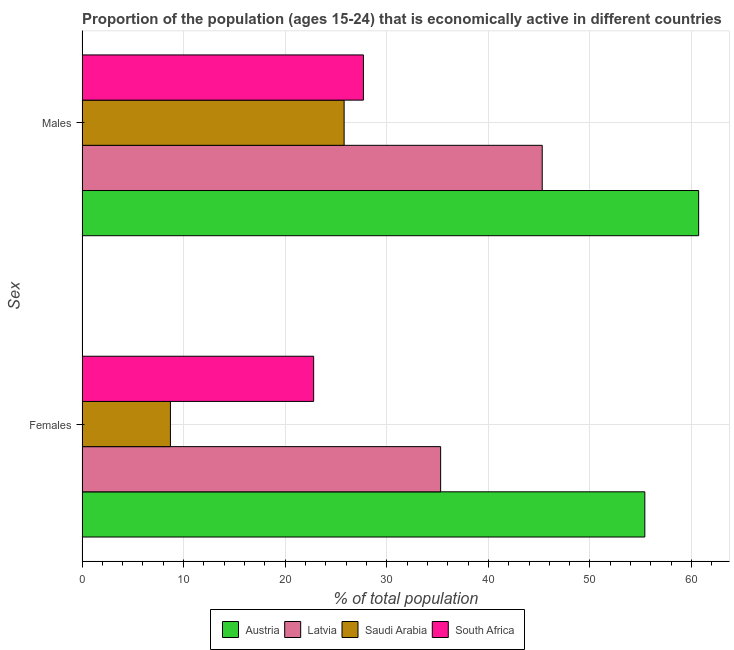Are the number of bars per tick equal to the number of legend labels?
Offer a terse response. Yes. Are the number of bars on each tick of the Y-axis equal?
Ensure brevity in your answer.  Yes. What is the label of the 2nd group of bars from the top?
Provide a succinct answer. Females. What is the percentage of economically active male population in Latvia?
Your answer should be compact. 45.3. Across all countries, what is the maximum percentage of economically active male population?
Offer a terse response. 60.7. Across all countries, what is the minimum percentage of economically active male population?
Offer a terse response. 25.8. In which country was the percentage of economically active female population minimum?
Keep it short and to the point. Saudi Arabia. What is the total percentage of economically active female population in the graph?
Make the answer very short. 122.2. What is the difference between the percentage of economically active female population in South Africa and that in Latvia?
Provide a succinct answer. -12.5. What is the difference between the percentage of economically active male population in Latvia and the percentage of economically active female population in South Africa?
Give a very brief answer. 22.5. What is the average percentage of economically active female population per country?
Ensure brevity in your answer.  30.55. What is the difference between the percentage of economically active male population and percentage of economically active female population in Latvia?
Provide a succinct answer. 10. What is the ratio of the percentage of economically active female population in Austria to that in Latvia?
Your response must be concise. 1.57. In how many countries, is the percentage of economically active female population greater than the average percentage of economically active female population taken over all countries?
Provide a succinct answer. 2. What does the 2nd bar from the top in Males represents?
Give a very brief answer. Saudi Arabia. What does the 2nd bar from the bottom in Females represents?
Make the answer very short. Latvia. How many bars are there?
Provide a short and direct response. 8. What is the difference between two consecutive major ticks on the X-axis?
Offer a terse response. 10. Where does the legend appear in the graph?
Provide a short and direct response. Bottom center. How many legend labels are there?
Your answer should be very brief. 4. What is the title of the graph?
Make the answer very short. Proportion of the population (ages 15-24) that is economically active in different countries. Does "Sub-Saharan Africa (developing only)" appear as one of the legend labels in the graph?
Offer a terse response. No. What is the label or title of the X-axis?
Make the answer very short. % of total population. What is the label or title of the Y-axis?
Give a very brief answer. Sex. What is the % of total population of Austria in Females?
Your answer should be compact. 55.4. What is the % of total population of Latvia in Females?
Ensure brevity in your answer.  35.3. What is the % of total population in Saudi Arabia in Females?
Your answer should be very brief. 8.7. What is the % of total population in South Africa in Females?
Offer a terse response. 22.8. What is the % of total population of Austria in Males?
Ensure brevity in your answer.  60.7. What is the % of total population in Latvia in Males?
Provide a succinct answer. 45.3. What is the % of total population in Saudi Arabia in Males?
Provide a succinct answer. 25.8. What is the % of total population of South Africa in Males?
Ensure brevity in your answer.  27.7. Across all Sex, what is the maximum % of total population of Austria?
Provide a succinct answer. 60.7. Across all Sex, what is the maximum % of total population in Latvia?
Provide a short and direct response. 45.3. Across all Sex, what is the maximum % of total population of Saudi Arabia?
Keep it short and to the point. 25.8. Across all Sex, what is the maximum % of total population in South Africa?
Offer a very short reply. 27.7. Across all Sex, what is the minimum % of total population in Austria?
Provide a succinct answer. 55.4. Across all Sex, what is the minimum % of total population of Latvia?
Ensure brevity in your answer.  35.3. Across all Sex, what is the minimum % of total population of Saudi Arabia?
Your answer should be very brief. 8.7. Across all Sex, what is the minimum % of total population of South Africa?
Provide a short and direct response. 22.8. What is the total % of total population of Austria in the graph?
Provide a short and direct response. 116.1. What is the total % of total population in Latvia in the graph?
Keep it short and to the point. 80.6. What is the total % of total population in Saudi Arabia in the graph?
Your answer should be compact. 34.5. What is the total % of total population in South Africa in the graph?
Ensure brevity in your answer.  50.5. What is the difference between the % of total population in Austria in Females and that in Males?
Your answer should be compact. -5.3. What is the difference between the % of total population of Saudi Arabia in Females and that in Males?
Ensure brevity in your answer.  -17.1. What is the difference between the % of total population in South Africa in Females and that in Males?
Give a very brief answer. -4.9. What is the difference between the % of total population of Austria in Females and the % of total population of Latvia in Males?
Offer a terse response. 10.1. What is the difference between the % of total population of Austria in Females and the % of total population of Saudi Arabia in Males?
Ensure brevity in your answer.  29.6. What is the difference between the % of total population of Austria in Females and the % of total population of South Africa in Males?
Offer a terse response. 27.7. What is the difference between the % of total population in Latvia in Females and the % of total population in Saudi Arabia in Males?
Ensure brevity in your answer.  9.5. What is the average % of total population in Austria per Sex?
Give a very brief answer. 58.05. What is the average % of total population in Latvia per Sex?
Provide a short and direct response. 40.3. What is the average % of total population in Saudi Arabia per Sex?
Provide a short and direct response. 17.25. What is the average % of total population in South Africa per Sex?
Make the answer very short. 25.25. What is the difference between the % of total population in Austria and % of total population in Latvia in Females?
Provide a succinct answer. 20.1. What is the difference between the % of total population of Austria and % of total population of Saudi Arabia in Females?
Make the answer very short. 46.7. What is the difference between the % of total population of Austria and % of total population of South Africa in Females?
Offer a very short reply. 32.6. What is the difference between the % of total population in Latvia and % of total population in Saudi Arabia in Females?
Your answer should be compact. 26.6. What is the difference between the % of total population in Latvia and % of total population in South Africa in Females?
Your answer should be compact. 12.5. What is the difference between the % of total population in Saudi Arabia and % of total population in South Africa in Females?
Provide a succinct answer. -14.1. What is the difference between the % of total population of Austria and % of total population of Saudi Arabia in Males?
Offer a very short reply. 34.9. What is the difference between the % of total population in Latvia and % of total population in South Africa in Males?
Offer a terse response. 17.6. What is the ratio of the % of total population of Austria in Females to that in Males?
Ensure brevity in your answer.  0.91. What is the ratio of the % of total population in Latvia in Females to that in Males?
Ensure brevity in your answer.  0.78. What is the ratio of the % of total population of Saudi Arabia in Females to that in Males?
Your response must be concise. 0.34. What is the ratio of the % of total population in South Africa in Females to that in Males?
Offer a terse response. 0.82. What is the difference between the highest and the second highest % of total population in Latvia?
Give a very brief answer. 10. What is the difference between the highest and the second highest % of total population of Saudi Arabia?
Your answer should be compact. 17.1. What is the difference between the highest and the second highest % of total population of South Africa?
Provide a short and direct response. 4.9. What is the difference between the highest and the lowest % of total population of Austria?
Offer a very short reply. 5.3. What is the difference between the highest and the lowest % of total population in Saudi Arabia?
Offer a very short reply. 17.1. 